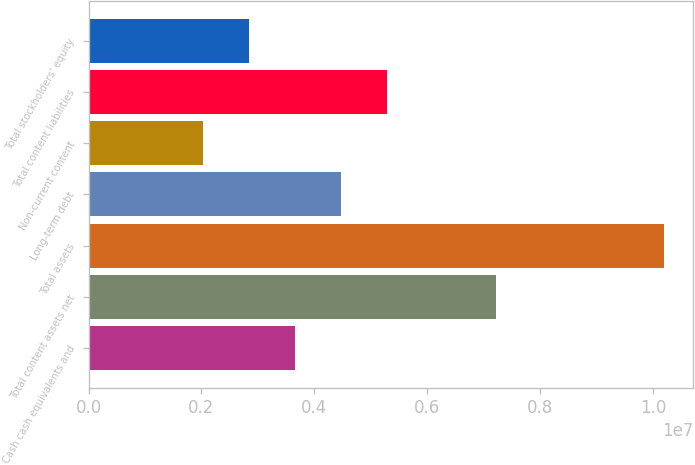Convert chart. <chart><loc_0><loc_0><loc_500><loc_500><bar_chart><fcel>Cash cash equivalents and<fcel>Total content assets net<fcel>Total assets<fcel>Long-term debt<fcel>Non-current content<fcel>Total content liabilities<fcel>Total stockholders' equity<nl><fcel>3.66166e+06<fcel>7.21882e+06<fcel>1.02029e+07<fcel>4.47931e+06<fcel>2.02636e+06<fcel>5.29696e+06<fcel>2.84401e+06<nl></chart> 